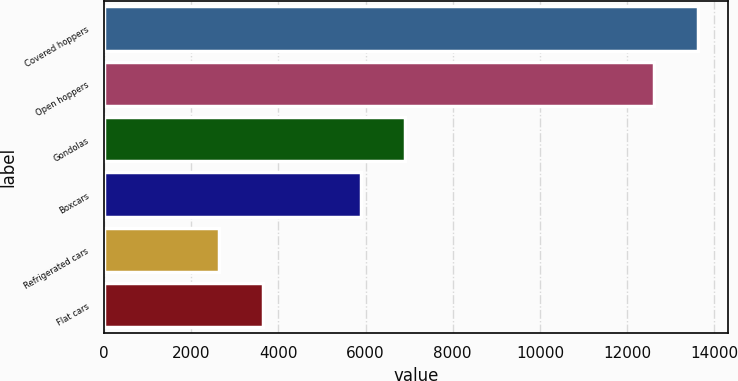Convert chart to OTSL. <chart><loc_0><loc_0><loc_500><loc_500><bar_chart><fcel>Covered hoppers<fcel>Open hoppers<fcel>Gondolas<fcel>Boxcars<fcel>Refrigerated cars<fcel>Flat cars<nl><fcel>13628.4<fcel>12615<fcel>6904.4<fcel>5891<fcel>2630<fcel>3643.4<nl></chart> 